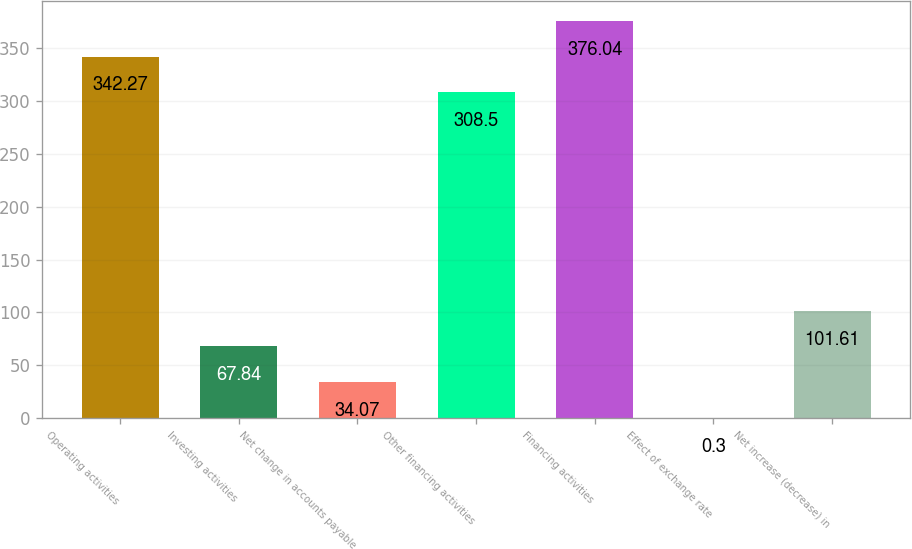Convert chart. <chart><loc_0><loc_0><loc_500><loc_500><bar_chart><fcel>Operating activities<fcel>Investing activities<fcel>Net change in accounts payable<fcel>Other financing activities<fcel>Financing activities<fcel>Effect of exchange rate<fcel>Net increase (decrease) in<nl><fcel>342.27<fcel>67.84<fcel>34.07<fcel>308.5<fcel>376.04<fcel>0.3<fcel>101.61<nl></chart> 